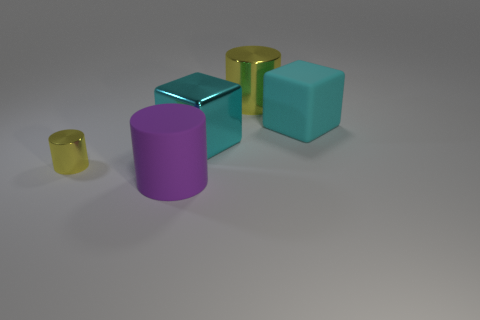Add 1 big cubes. How many objects exist? 6 Subtract all cylinders. How many objects are left? 2 Add 5 yellow metal spheres. How many yellow metal spheres exist? 5 Subtract 0 green balls. How many objects are left? 5 Subtract all blue shiny objects. Subtract all cyan metallic blocks. How many objects are left? 4 Add 2 purple rubber objects. How many purple rubber objects are left? 3 